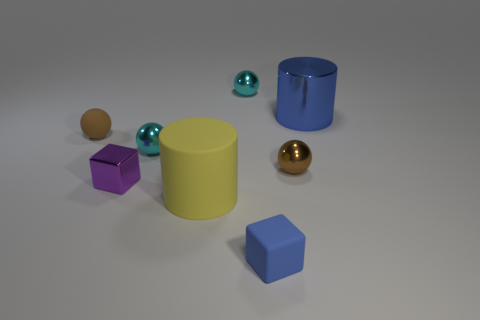Is the color of the big object behind the brown rubber thing the same as the tiny block in front of the tiny metal cube?
Keep it short and to the point. Yes. How many other things are there of the same color as the large rubber thing?
Keep it short and to the point. 0. How many gray things are big cylinders or rubber cubes?
Ensure brevity in your answer.  0. Do the big matte object and the blue object on the right side of the rubber block have the same shape?
Provide a succinct answer. Yes. What is the shape of the blue matte object?
Keep it short and to the point. Cube. There is another brown thing that is the same size as the brown shiny object; what is its material?
Your answer should be compact. Rubber. How many objects are either small spheres or rubber objects that are behind the small purple metal thing?
Your response must be concise. 4. The blue cylinder that is made of the same material as the purple object is what size?
Keep it short and to the point. Large. The small object on the left side of the small cube behind the yellow object is what shape?
Give a very brief answer. Sphere. What size is the metal object that is behind the brown shiny object and on the right side of the matte block?
Provide a succinct answer. Large. 